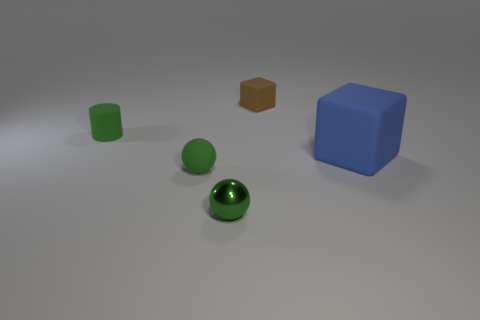Are there more tiny rubber blocks on the right side of the big blue thing than matte spheres left of the small green rubber ball?
Offer a very short reply. No. Are there any green shiny cylinders that have the same size as the metal sphere?
Provide a succinct answer. No. What is the size of the blue matte thing that is on the right side of the small thing behind the small green object behind the big thing?
Give a very brief answer. Large. What is the color of the large block?
Ensure brevity in your answer.  Blue. Is the number of brown objects that are behind the large blue rubber object greater than the number of large cyan cubes?
Make the answer very short. Yes. There is a green metallic object; what number of tiny things are in front of it?
Provide a short and direct response. 0. The tiny metallic object that is the same color as the rubber cylinder is what shape?
Keep it short and to the point. Sphere. Are there any tiny objects that are in front of the tiny green matte thing that is in front of the matte thing that is right of the tiny brown rubber block?
Provide a succinct answer. Yes. Is the brown matte cube the same size as the blue block?
Make the answer very short. No. Are there an equal number of large rubber blocks behind the brown block and big objects in front of the tiny matte cylinder?
Provide a succinct answer. No. 